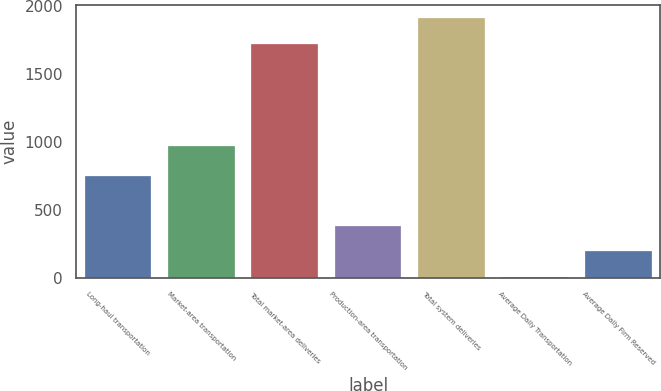Convert chart to OTSL. <chart><loc_0><loc_0><loc_500><loc_500><bar_chart><fcel>Long-haul transportation<fcel>Market-area transportation<fcel>Total market-area deliveries<fcel>Production-area transportation<fcel>Total system deliveries<fcel>Average Daily Transportation<fcel>Average Daily Firm Reserved<nl><fcel>753<fcel>969<fcel>1722<fcel>386.16<fcel>1912.48<fcel>5.2<fcel>195.68<nl></chart> 